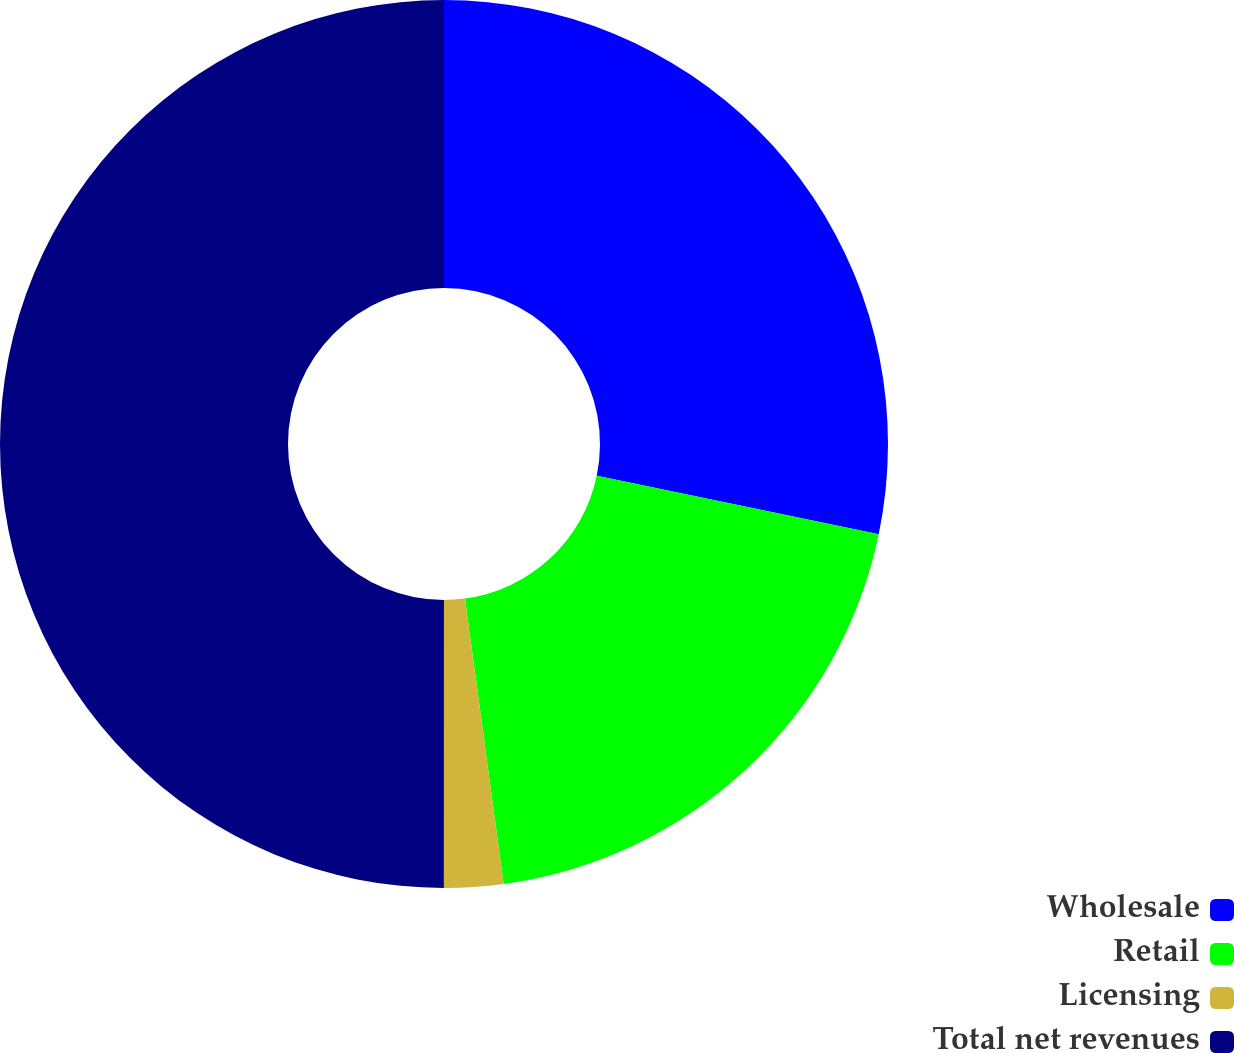<chart> <loc_0><loc_0><loc_500><loc_500><pie_chart><fcel>Wholesale<fcel>Retail<fcel>Licensing<fcel>Total net revenues<nl><fcel>28.26%<fcel>19.6%<fcel>2.15%<fcel>50.0%<nl></chart> 